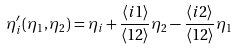<formula> <loc_0><loc_0><loc_500><loc_500>\eta ^ { \prime } _ { i } ( \eta _ { 1 } , \eta _ { 2 } ) = \eta _ { i } + \frac { \langle i 1 \rangle } { \langle 1 2 \rangle } \eta _ { 2 } - \frac { \langle i 2 \rangle } { \langle 1 2 \rangle } \eta _ { 1 }</formula> 